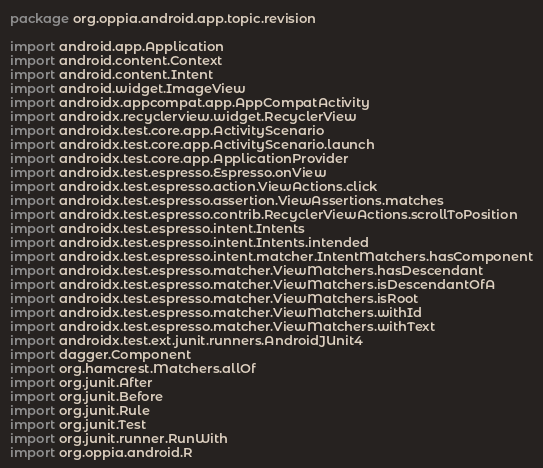<code> <loc_0><loc_0><loc_500><loc_500><_Kotlin_>package org.oppia.android.app.topic.revision

import android.app.Application
import android.content.Context
import android.content.Intent
import android.widget.ImageView
import androidx.appcompat.app.AppCompatActivity
import androidx.recyclerview.widget.RecyclerView
import androidx.test.core.app.ActivityScenario
import androidx.test.core.app.ActivityScenario.launch
import androidx.test.core.app.ApplicationProvider
import androidx.test.espresso.Espresso.onView
import androidx.test.espresso.action.ViewActions.click
import androidx.test.espresso.assertion.ViewAssertions.matches
import androidx.test.espresso.contrib.RecyclerViewActions.scrollToPosition
import androidx.test.espresso.intent.Intents
import androidx.test.espresso.intent.Intents.intended
import androidx.test.espresso.intent.matcher.IntentMatchers.hasComponent
import androidx.test.espresso.matcher.ViewMatchers.hasDescendant
import androidx.test.espresso.matcher.ViewMatchers.isDescendantOfA
import androidx.test.espresso.matcher.ViewMatchers.isRoot
import androidx.test.espresso.matcher.ViewMatchers.withId
import androidx.test.espresso.matcher.ViewMatchers.withText
import androidx.test.ext.junit.runners.AndroidJUnit4
import dagger.Component
import org.hamcrest.Matchers.allOf
import org.junit.After
import org.junit.Before
import org.junit.Rule
import org.junit.Test
import org.junit.runner.RunWith
import org.oppia.android.R</code> 